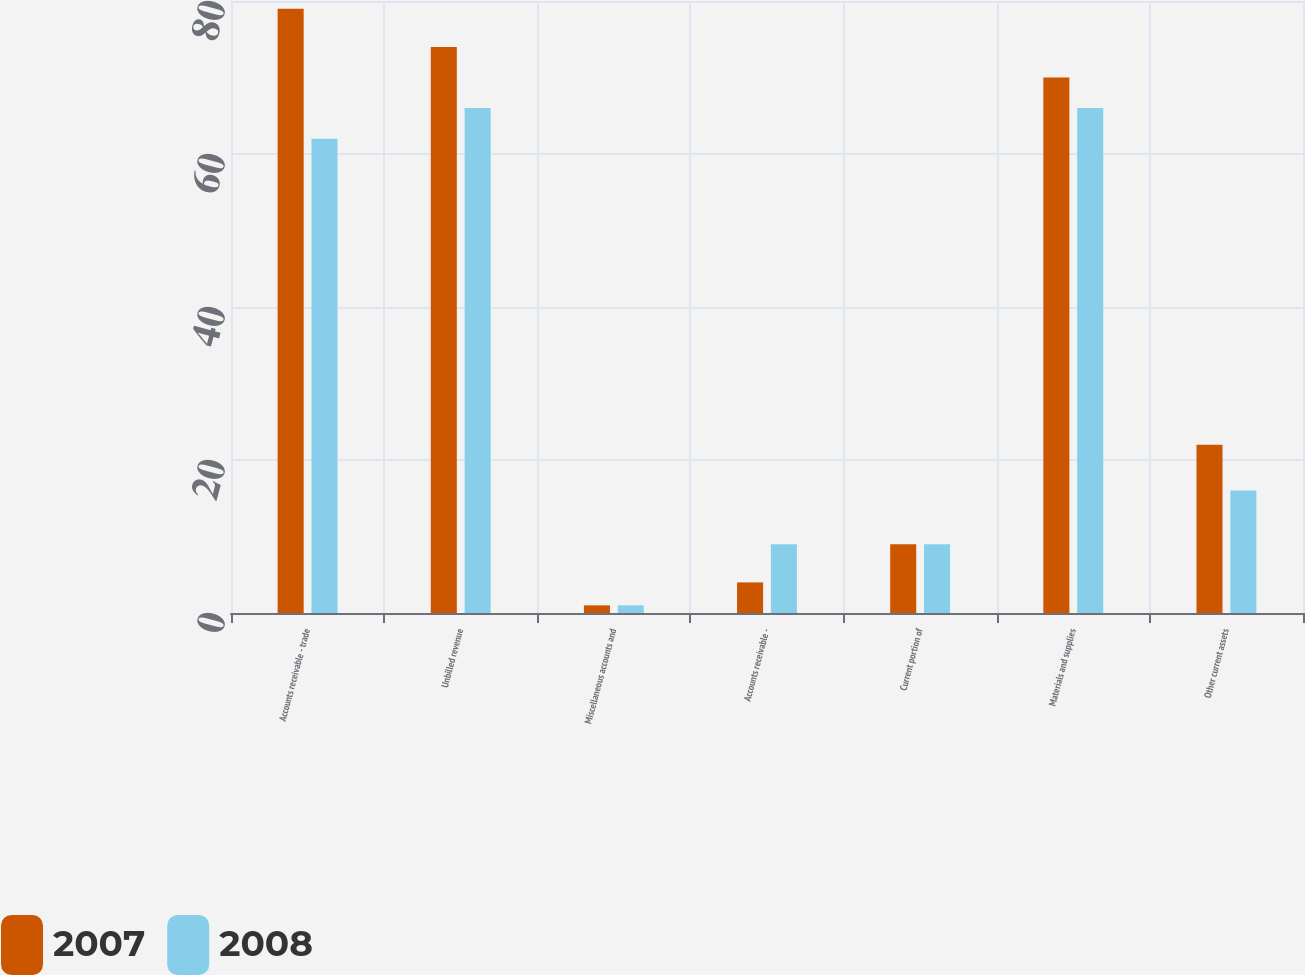Convert chart. <chart><loc_0><loc_0><loc_500><loc_500><stacked_bar_chart><ecel><fcel>Accounts receivable - trade<fcel>Unbilled revenue<fcel>Miscellaneous accounts and<fcel>Accounts receivable -<fcel>Current portion of<fcel>Materials and supplies<fcel>Other current assets<nl><fcel>2007<fcel>79<fcel>74<fcel>1<fcel>4<fcel>9<fcel>70<fcel>22<nl><fcel>2008<fcel>62<fcel>66<fcel>1<fcel>9<fcel>9<fcel>66<fcel>16<nl></chart> 